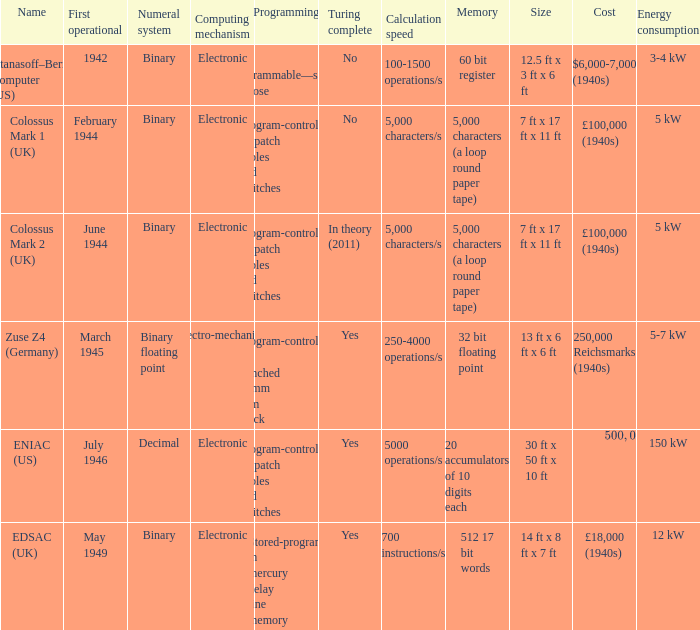What's the turing complete with numeral system being decimal Yes. 